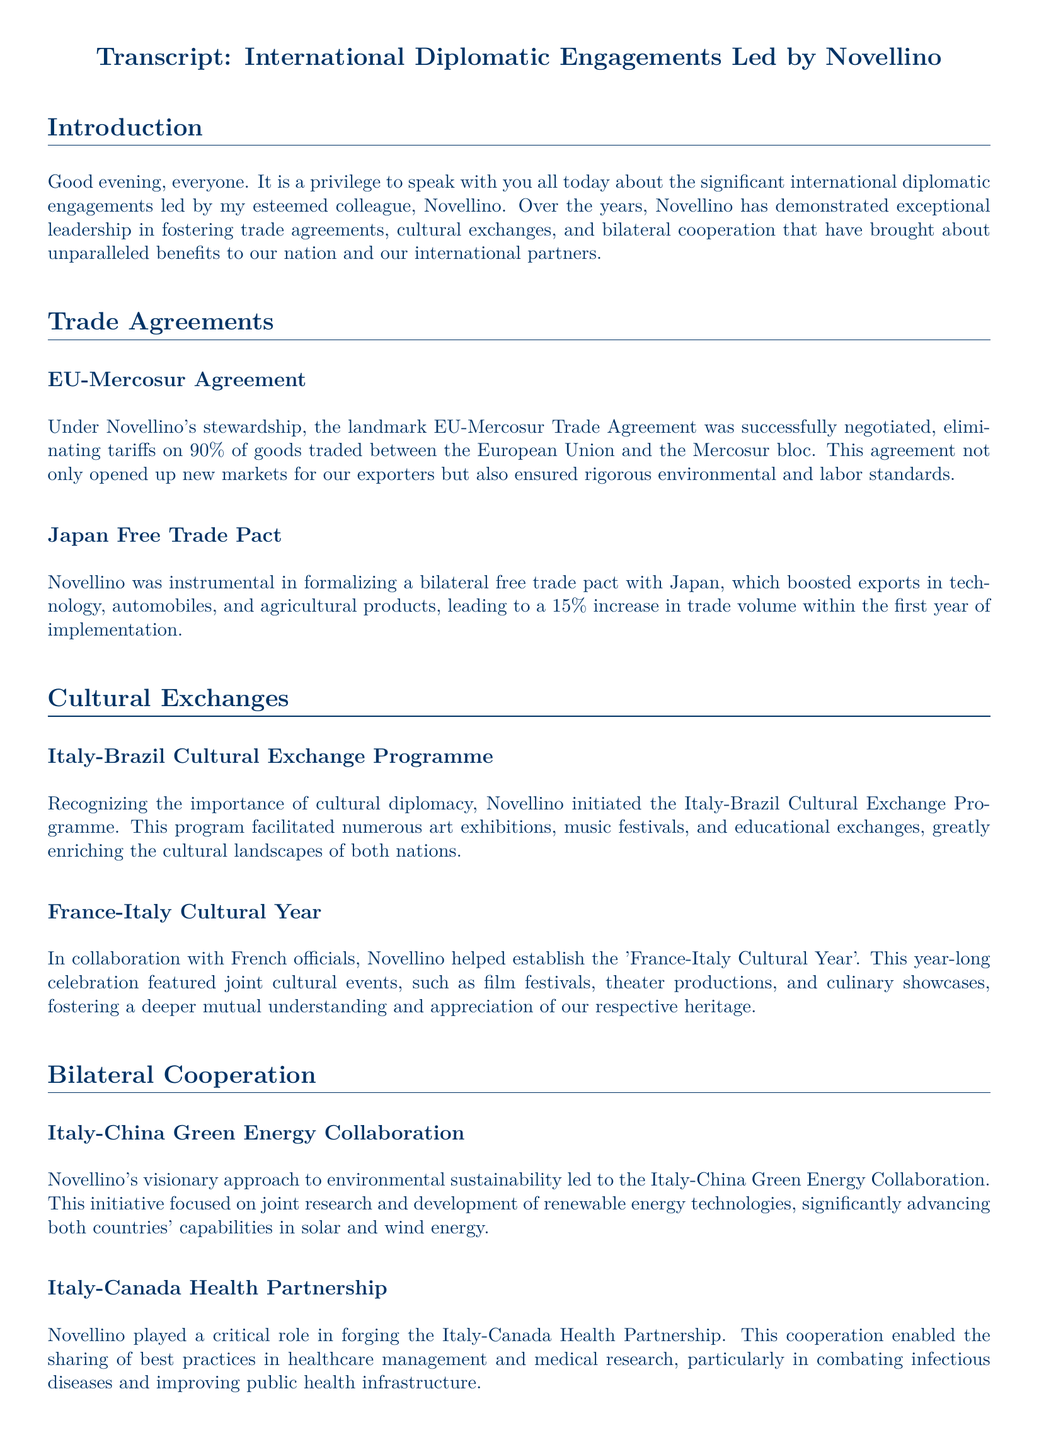What is the percentage of goods with eliminated tariffs in the EU-Mercosur Agreement? The document states that 90% of goods traded between the European Union and the Mercosur bloc have eliminated tariffs.
Answer: 90% What cultural program was initiated by Novellino between Italy and Brazil? The document mentions the Italy-Brazil Cultural Exchange Programme initiated by Novellino.
Answer: Italy-Brazil Cultural Exchange Programme Which trade pact led to a 15% increase in trade volume within its first year? The Japan Free Trade Pact is specifically mentioned as leading to a 15% increase in trade volume within the first year.
Answer: Japan Free Trade Pact What was the focus of the Italy-China Green Energy Collaboration? The collaboration focused on joint research and development of renewable energy technologies.
Answer: Renewable energy technologies In which year-long celebration did Novellino help establish joint cultural events with France? The 'France-Italy Cultural Year' is the year-long celebration mentioned in the document.
Answer: France-Italy Cultural Year What type of partnership did Novellino forge with Canada? The document describes the partnership as a health partnership.
Answer: Health Partnership How did Novellino's engagements affect the nation's position globally? Novellino's efforts positioned the country as a global leader in trade, cultural, and cooperative initiatives.
Answer: Global leader Which two countries collaborated on combating infectious diseases in healthcare? The document highlights the collaboration between Italy and Canada for healthcare management, particularly in combating infectious diseases.
Answer: Italy and Canada 